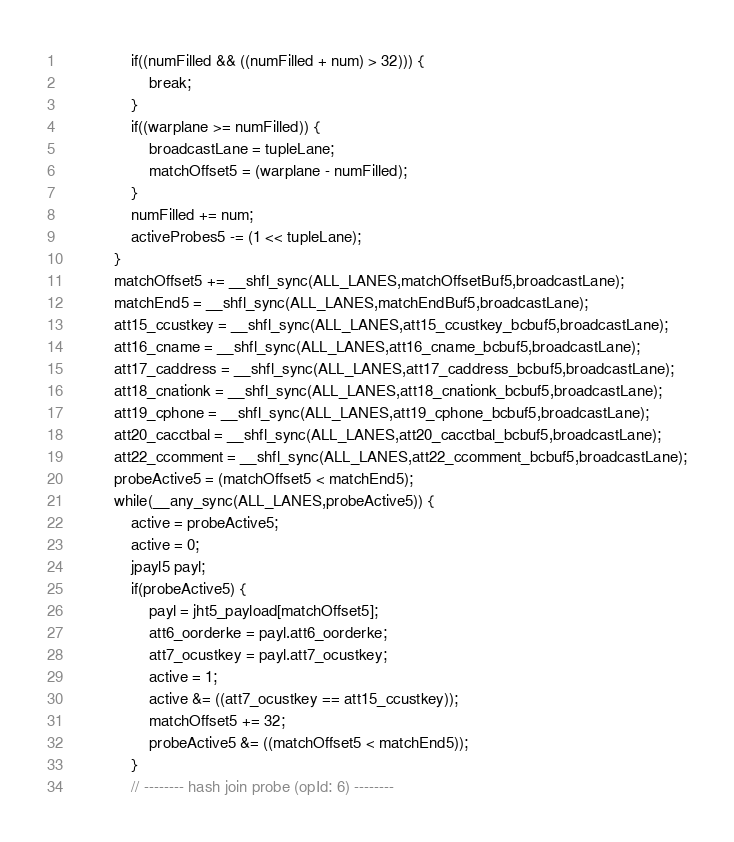Convert code to text. <code><loc_0><loc_0><loc_500><loc_500><_Cuda_>                if((numFilled && ((numFilled + num) > 32))) {
                    break;
                }
                if((warplane >= numFilled)) {
                    broadcastLane = tupleLane;
                    matchOffset5 = (warplane - numFilled);
                }
                numFilled += num;
                activeProbes5 -= (1 << tupleLane);
            }
            matchOffset5 += __shfl_sync(ALL_LANES,matchOffsetBuf5,broadcastLane);
            matchEnd5 = __shfl_sync(ALL_LANES,matchEndBuf5,broadcastLane);
            att15_ccustkey = __shfl_sync(ALL_LANES,att15_ccustkey_bcbuf5,broadcastLane);
            att16_cname = __shfl_sync(ALL_LANES,att16_cname_bcbuf5,broadcastLane);
            att17_caddress = __shfl_sync(ALL_LANES,att17_caddress_bcbuf5,broadcastLane);
            att18_cnationk = __shfl_sync(ALL_LANES,att18_cnationk_bcbuf5,broadcastLane);
            att19_cphone = __shfl_sync(ALL_LANES,att19_cphone_bcbuf5,broadcastLane);
            att20_cacctbal = __shfl_sync(ALL_LANES,att20_cacctbal_bcbuf5,broadcastLane);
            att22_ccomment = __shfl_sync(ALL_LANES,att22_ccomment_bcbuf5,broadcastLane);
            probeActive5 = (matchOffset5 < matchEnd5);
            while(__any_sync(ALL_LANES,probeActive5)) {
                active = probeActive5;
                active = 0;
                jpayl5 payl;
                if(probeActive5) {
                    payl = jht5_payload[matchOffset5];
                    att6_oorderke = payl.att6_oorderke;
                    att7_ocustkey = payl.att7_ocustkey;
                    active = 1;
                    active &= ((att7_ocustkey == att15_ccustkey));
                    matchOffset5 += 32;
                    probeActive5 &= ((matchOffset5 < matchEnd5));
                }
                // -------- hash join probe (opId: 6) --------</code> 